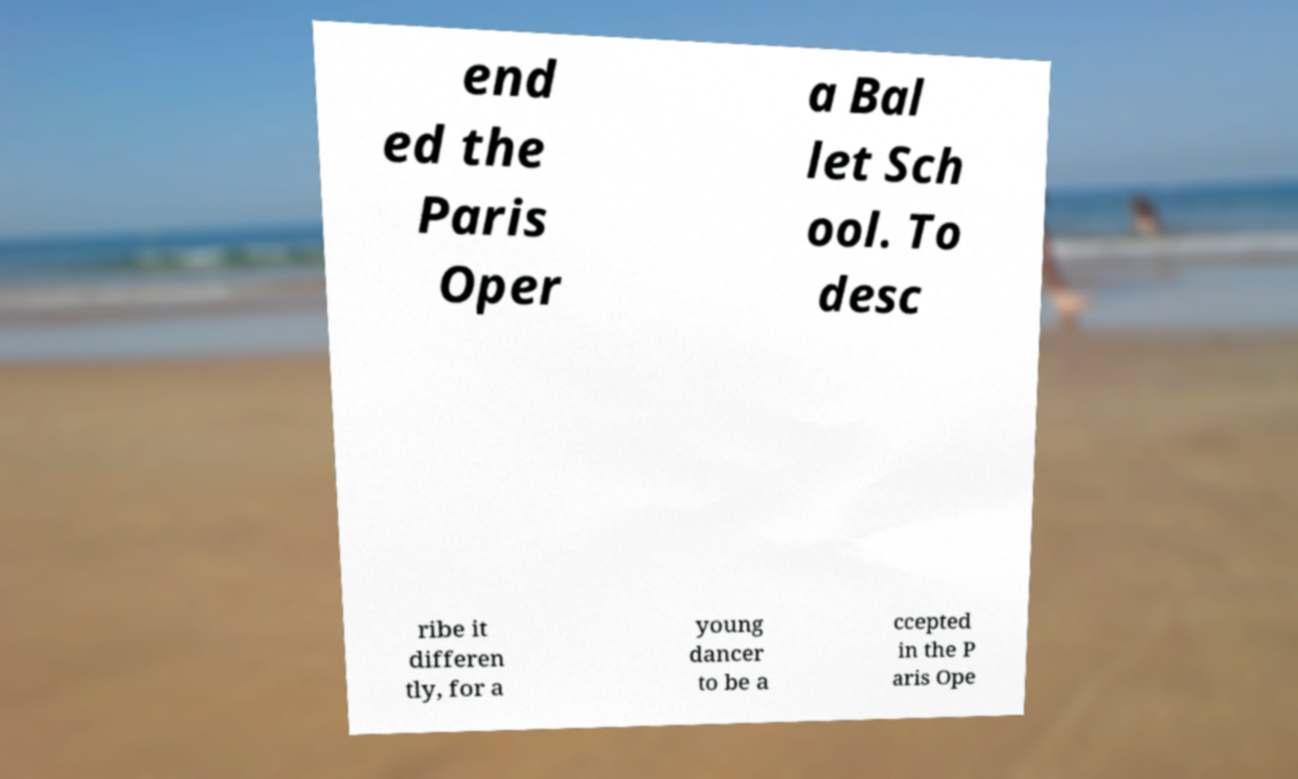What messages or text are displayed in this image? I need them in a readable, typed format. end ed the Paris Oper a Bal let Sch ool. To desc ribe it differen tly, for a young dancer to be a ccepted in the P aris Ope 